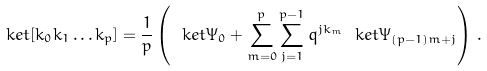Convert formula to latex. <formula><loc_0><loc_0><loc_500><loc_500>\ k e t { \left [ k _ { 0 } k _ { 1 } \dots k _ { p } \right ] } = \frac { 1 } { p } \left ( \ k e t { \Psi _ { 0 } } + \sum _ { m = 0 } ^ { p } \sum _ { j = 1 } ^ { p - 1 } q ^ { j k _ { m } } \ k e t { \Psi _ { ( p - 1 ) m + j } } \right ) \, .</formula> 